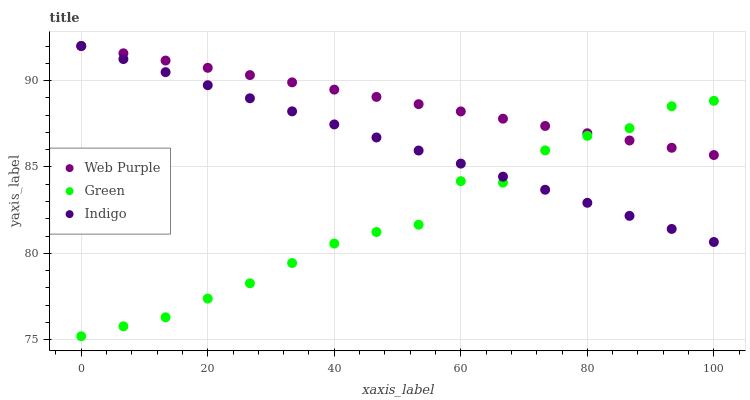Does Green have the minimum area under the curve?
Answer yes or no. Yes. Does Web Purple have the maximum area under the curve?
Answer yes or no. Yes. Does Web Purple have the minimum area under the curve?
Answer yes or no. No. Does Green have the maximum area under the curve?
Answer yes or no. No. Is Web Purple the smoothest?
Answer yes or no. Yes. Is Green the roughest?
Answer yes or no. Yes. Is Green the smoothest?
Answer yes or no. No. Is Web Purple the roughest?
Answer yes or no. No. Does Green have the lowest value?
Answer yes or no. Yes. Does Web Purple have the lowest value?
Answer yes or no. No. Does Web Purple have the highest value?
Answer yes or no. Yes. Does Green have the highest value?
Answer yes or no. No. Does Green intersect Indigo?
Answer yes or no. Yes. Is Green less than Indigo?
Answer yes or no. No. Is Green greater than Indigo?
Answer yes or no. No. 